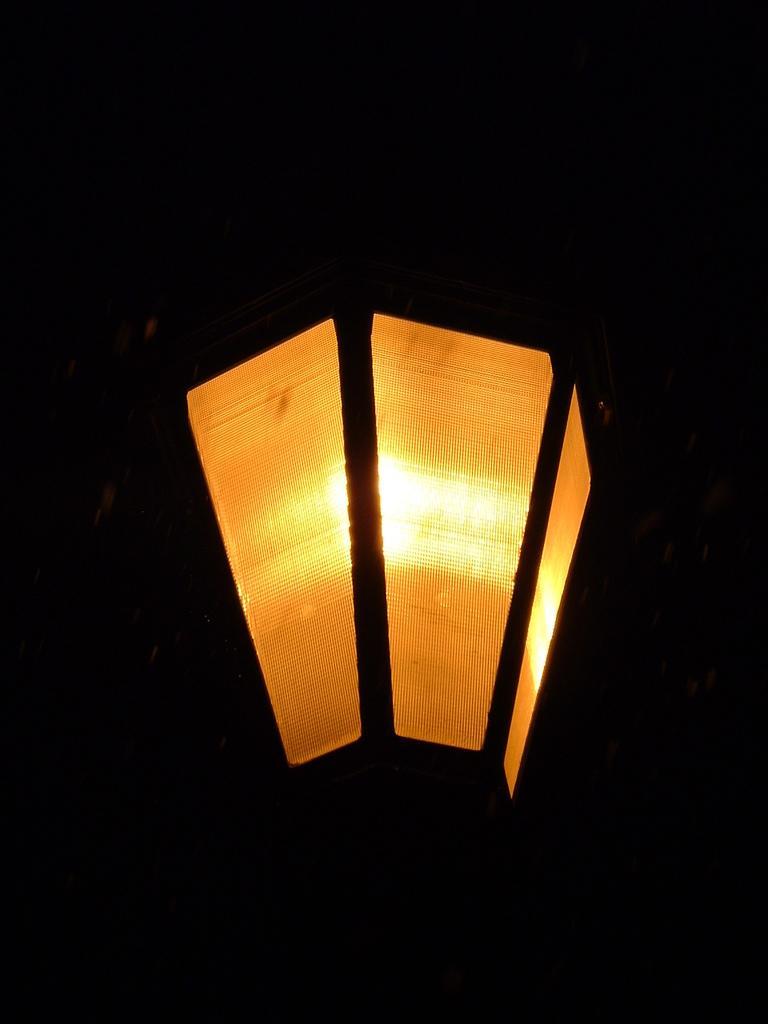Could you give a brief overview of what you see in this image? In this image we can able to a street light. 